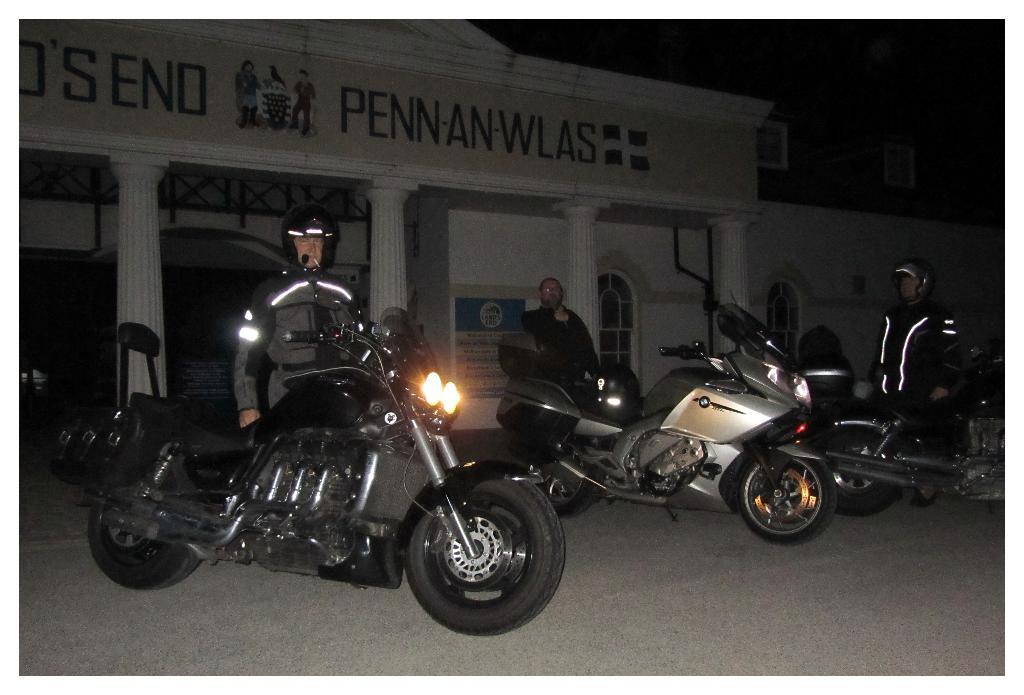What can be seen in the image? There are bikes and persons standing in the image. What is visible in the background of the image? There are buildings and pillars in the background of the image. Can you describe the text on the pillars? The text is written on the top of the pillars. How many chairs are placed around the desk in the image? There is no desk or chairs present in the image. What is the color of the mouth of the person in the image? There is no mouth visible in the image; only the bikes and persons standing are present. 